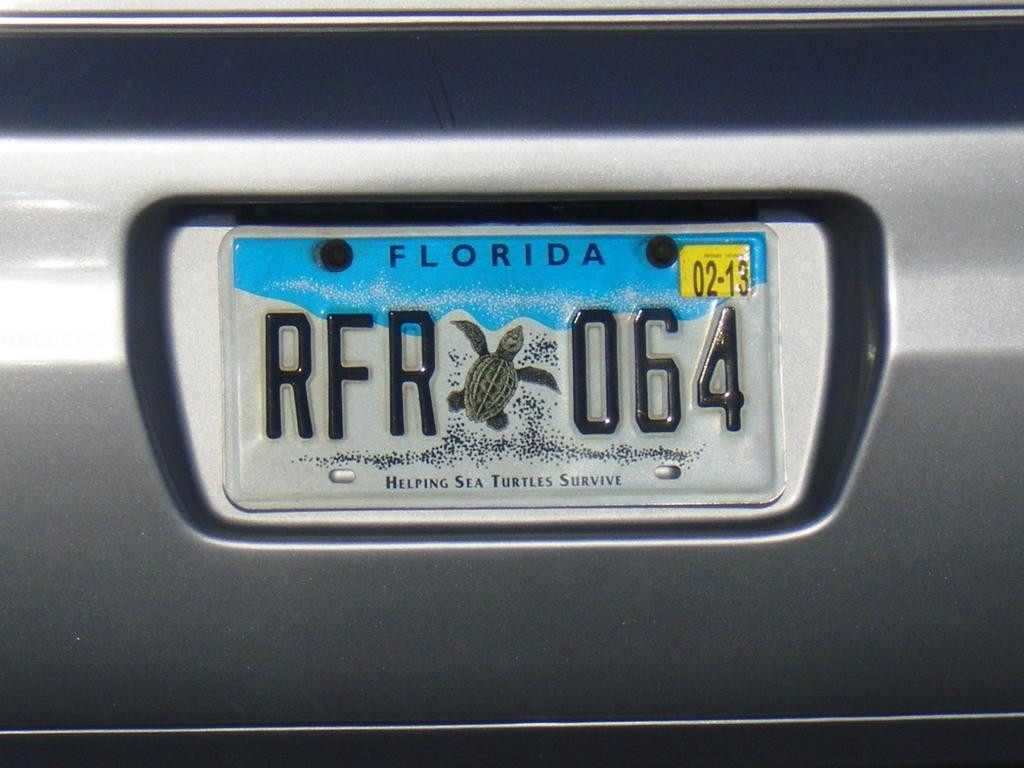<image>
Share a concise interpretation of the image provided. a florida license plate that has many numbers on it 